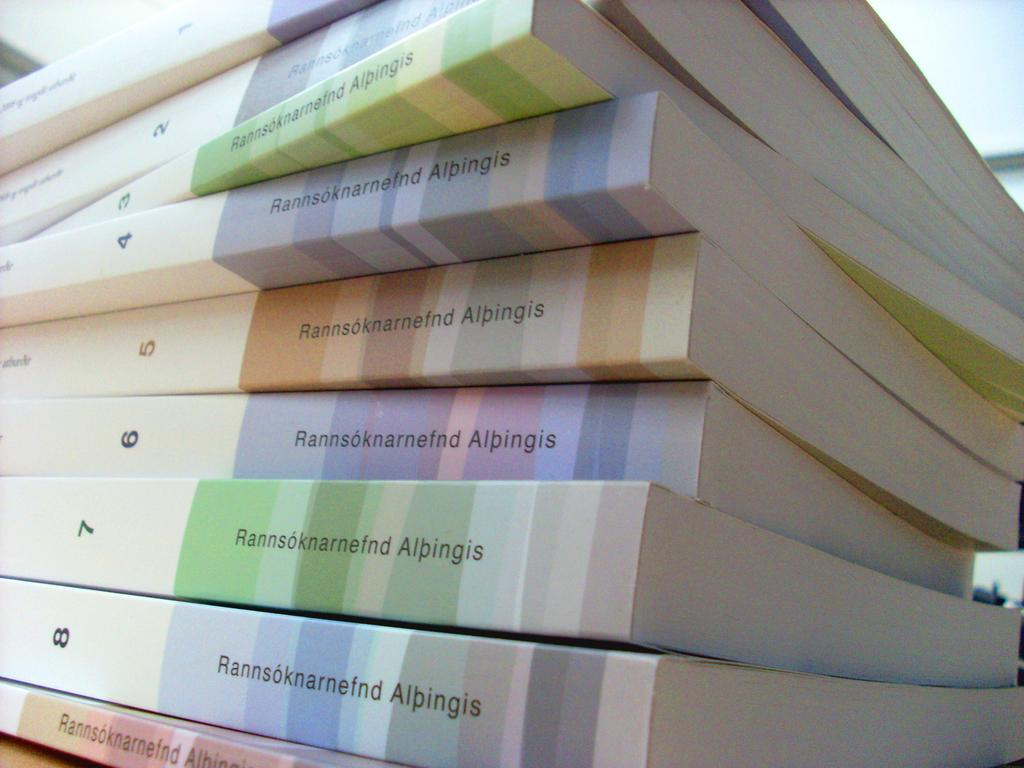<image>
Offer a succinct explanation of the picture presented. Volumes 1-8 of Rannsoknarnefnd Alpingis has pastel colored book spines. 